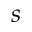Convert formula to latex. <formula><loc_0><loc_0><loc_500><loc_500>s</formula> 